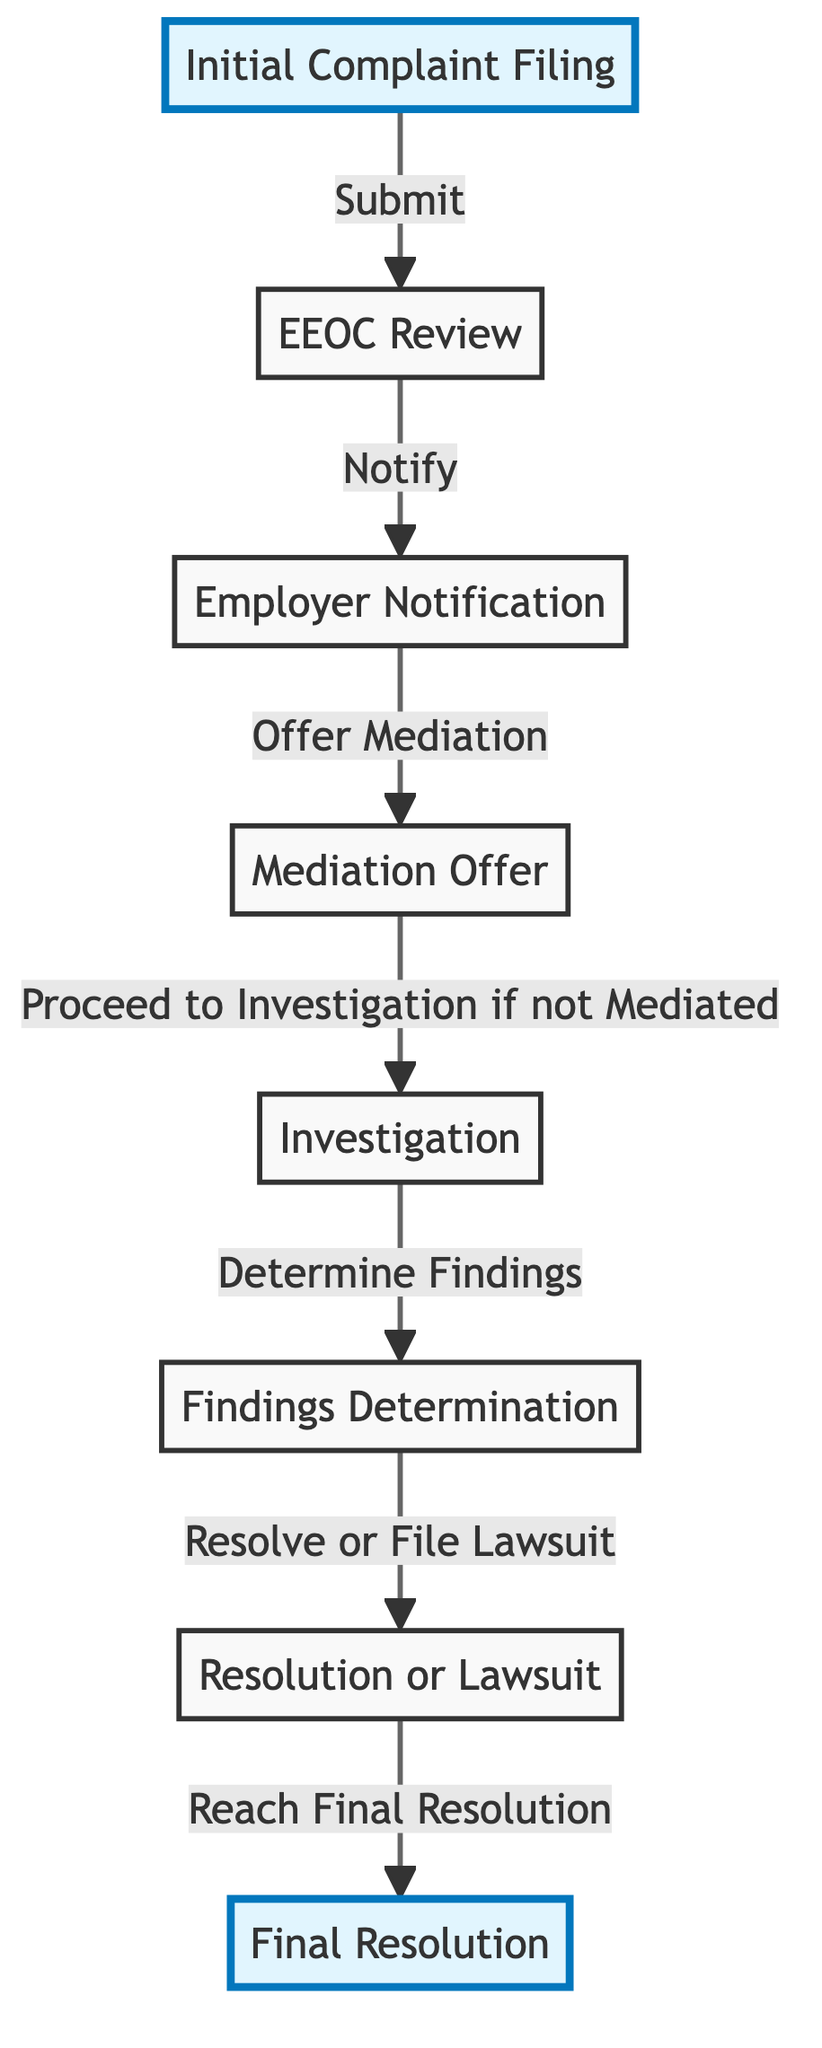What is the first step in the lifecycle of a discrimination case? The diagram indicates that the first step is "Initial Complaint Filing." This can be directly viewed as the starting node in the flowchart.
Answer: Initial Complaint Filing How many total nodes are present in the diagram? By counting the distinct points in the flowchart, we identify eight nodes representing different stages in the case process.
Answer: 8 What action takes place after the EEOC Review? The next action following the "EEOC Review" node is "Employer Notification," showing a direct connection between these two stages in the process.
Answer: Employer Notification If mediation is not accepted, what step follows? The diagram clearly states that if mediation is not accepted, the process proceeds to "Investigation," indicating the route taken when mediation fails.
Answer: Investigation What is the final outcome in the lifecycle of a discrimination case? The last node in the flowchart represents the "Final Resolution," which indicates the concluding stage of the case lifecycle.
Answer: Final Resolution How many edges connect the nodes in this diagram? Analyzing the flowchart's connections shows there are seven edges that illustrate the transitions between the various stages in the case process.
Answer: 7 What does the mediation offer node directly lead to? The node labeled "Mediation Offer" leads to either proceeding to "Investigation" if mediation does not occur, highlighting its conditional nature in the flowchart.
Answer: Investigation Which phases of the case lifecycle involve findings? The "Investigation" phase leads to "Findings Determination"; thus, both of these phases are connected through the evaluative aspect of the case.
Answer: Investigation, Findings Determination 